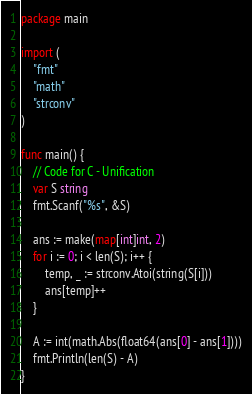Convert code to text. <code><loc_0><loc_0><loc_500><loc_500><_Go_>package main

import (
	"fmt"
	"math"
	"strconv"
)

func main() {
	// Code for C - Unification
	var S string
	fmt.Scanf("%s", &S)

	ans := make(map[int]int, 2)
	for i := 0; i < len(S); i++ {
		temp, _ := strconv.Atoi(string(S[i]))
		ans[temp]++
	}

	A := int(math.Abs(float64(ans[0] - ans[1])))
	fmt.Println(len(S) - A)
}
</code> 